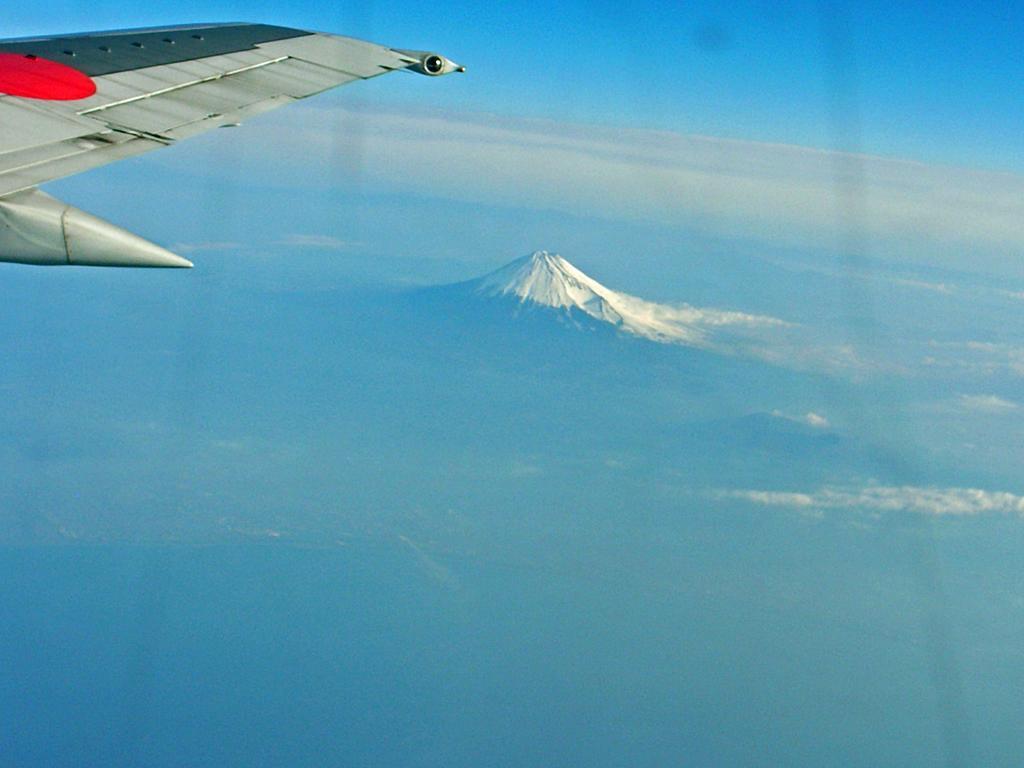Please provide a concise description of this image. In this image I can see the wing of the aeroplane which is grey, black and red in color which is flying in the air. In the background I can see a mountain and the sky. 